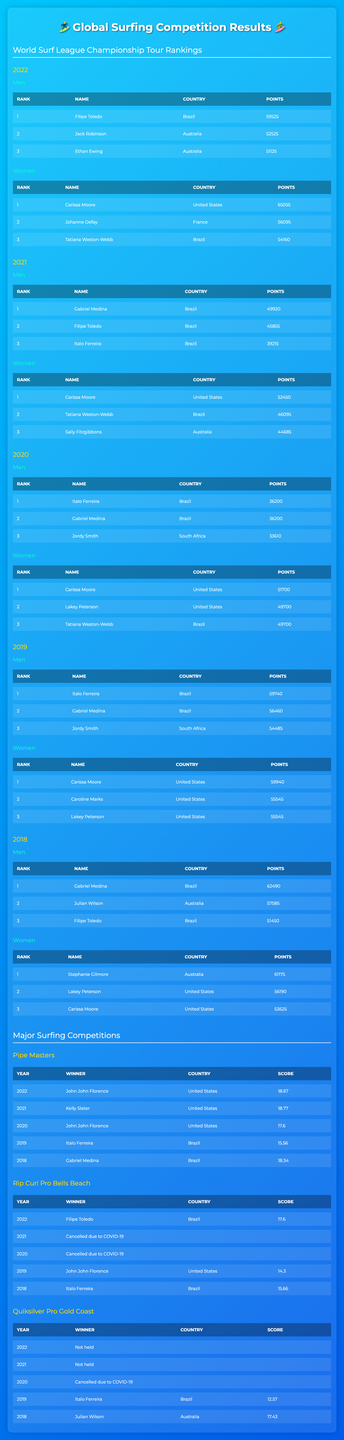What was the rank of Carissa Moore in 2022? Carissa Moore is listed under the Women’s rankings for 2022 and her rank is mentioned as 1.
Answer: 1 Who won the Pipe Masters in 2020? The Pipe Masters entry for 2020 shows that the winner was John John Florence.
Answer: John John Florence In which year did Filipe Toledo achieve the highest points? To find out, we compare his points across the years listed; in 2022, he has 59525 points, which is higher than any other year.
Answer: 2022 What was the score of the winner of the Rip Curl Pro Bells Beach in 2019? The table entry shows that John John Florence won the Rip Curl Pro Bells Beach in 2019 with a score of 14.30.
Answer: 14.30 How many points did the women's champion earn in 2021 compared to the champion in 2020? Carissa Moore earned 52450 points in 2021, while the champion in 2020 (also Carissa Moore) earned 51700 points. Thus, 52450 - 51700 = 750 points difference.
Answer: 750 Did Italo Ferreira win the Rip Curl Pro Bells Beach in 2018? The entry for Rip Curl Pro Bells Beach in 2018 shows that Italo Ferreira was the winner.
Answer: Yes What's the total score of the top 3 women surfers in 2022? To find this, we sum the points from the top 3 women surfers: Carissa Moore (65055) + Johanne Defay (56095) + Tatiana Weston-Webb (54160) = 185310 total points.
Answer: 185310 Which country had the most representations in the top ranks over the last five years? By analyzing the top ranks of the men’s and women’s categories, Brazil had prominent representations in both genders, especially with multiple champions over the years.
Answer: Brazil What was the highest score by a winner in the Major Surfing Competitions from 2018 to 2022? The highest score was by Kelly Slater in the Pipe Masters 2021 with 18.77, compared to all other winners listed.
Answer: 18.77 Was the Rip Curl Pro Bells Beach held in both 2021 and 2020? The entries confirm that the Rip Curl Pro Bells Beach was cancelled due to COVID-19 in both years.
Answer: Yes 